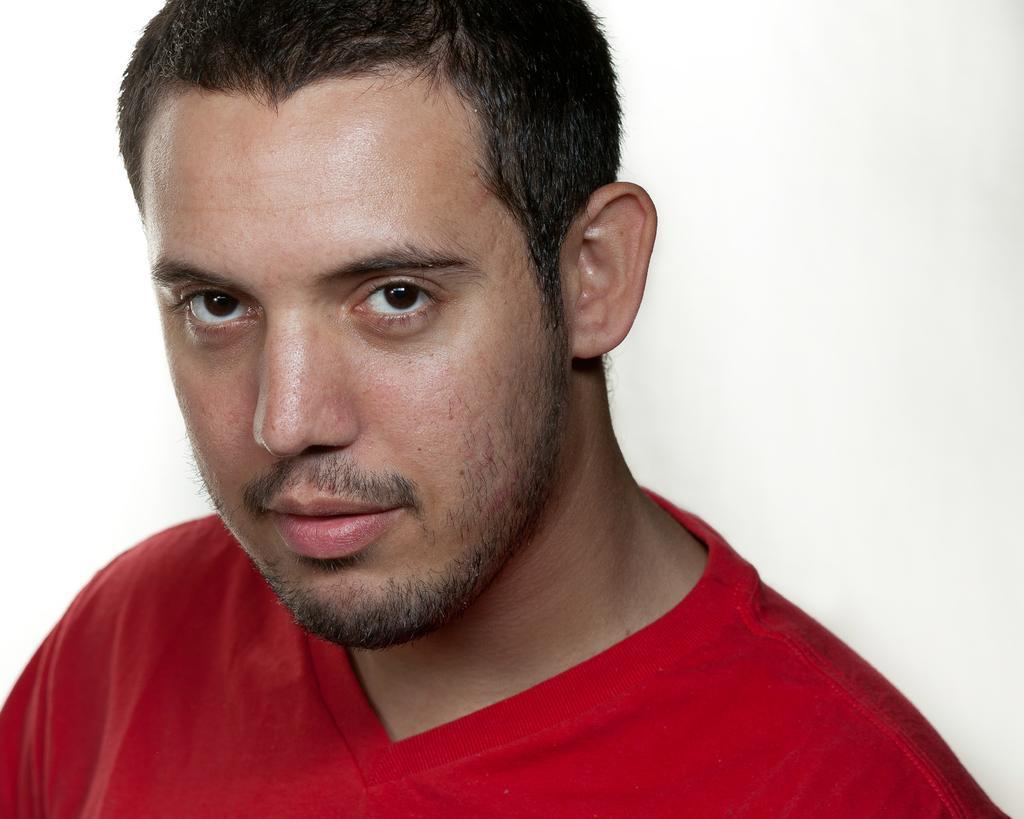In one or two sentences, can you explain what this image depicts? In the picture I can see a person wearing red T-shirt and the background is in white color. 